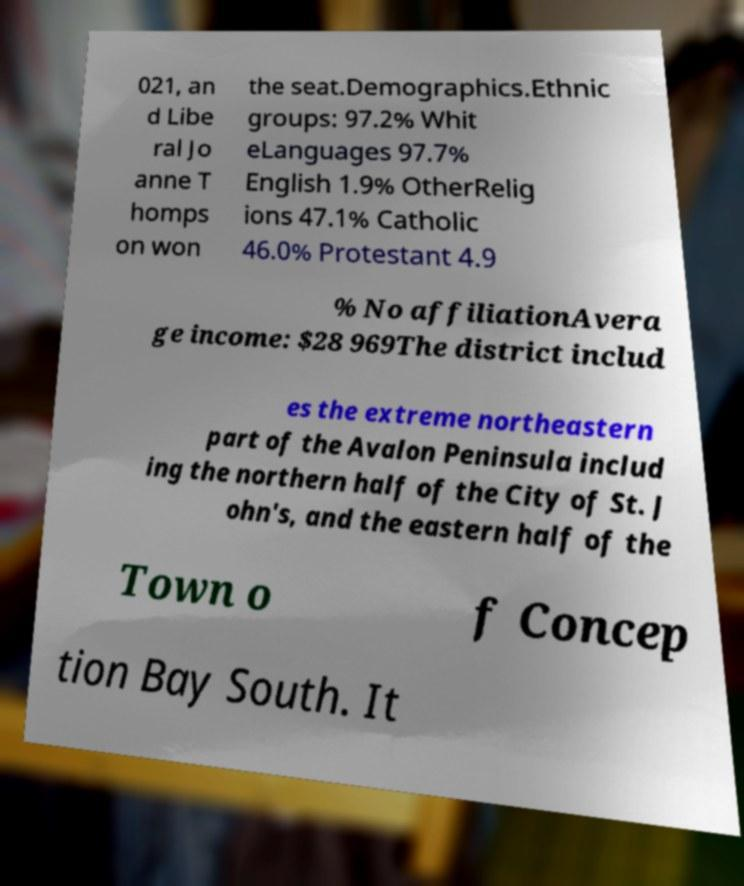What messages or text are displayed in this image? I need them in a readable, typed format. 021, an d Libe ral Jo anne T homps on won the seat.Demographics.Ethnic groups: 97.2% Whit eLanguages 97.7% English 1.9% OtherRelig ions 47.1% Catholic 46.0% Protestant 4.9 % No affiliationAvera ge income: $28 969The district includ es the extreme northeastern part of the Avalon Peninsula includ ing the northern half of the City of St. J ohn's, and the eastern half of the Town o f Concep tion Bay South. It 